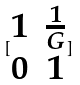Convert formula to latex. <formula><loc_0><loc_0><loc_500><loc_500>[ \begin{matrix} 1 & \frac { 1 } { G } \\ 0 & 1 \end{matrix} ]</formula> 